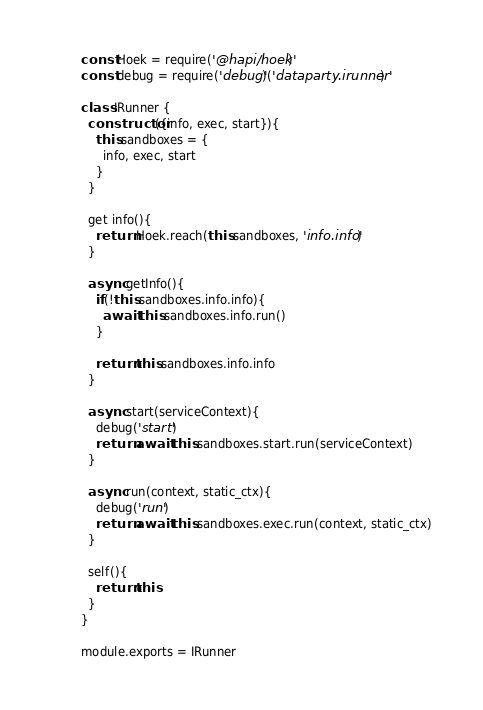Convert code to text. <code><loc_0><loc_0><loc_500><loc_500><_JavaScript_>const Hoek = require('@hapi/hoek')
const debug = require('debug')('dataparty.irunner')

class IRunner {
  constructor({info, exec, start}){
    this.sandboxes = {
      info, exec, start
    }
  }

  get info(){
    return Hoek.reach(this.sandboxes, 'info.info')
  }

  async getInfo(){
    if(!this.sandboxes.info.info){
      await this.sandboxes.info.run()
    }

    return this.sandboxes.info.info
  }

  async start(serviceContext){
    debug('start')
    return await this.sandboxes.start.run(serviceContext)
  }

  async run(context, static_ctx){
    debug('run')
    return await this.sandboxes.exec.run(context, static_ctx)
  }

  self(){
    return this
  }
}

module.exports = IRunner</code> 